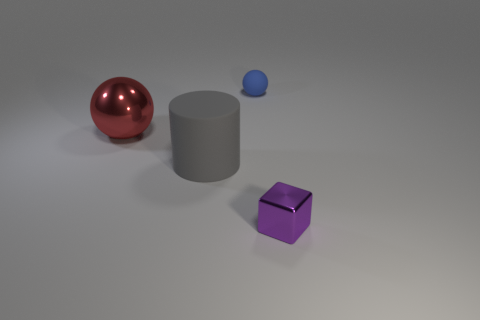There is a shiny object that is right of the matte cylinder; what shape is it?
Offer a very short reply. Cube. How many green objects are tiny metal blocks or big rubber objects?
Offer a terse response. 0. There is a sphere that is made of the same material as the big cylinder; what color is it?
Provide a short and direct response. Blue. Do the big ball and the tiny object right of the small blue ball have the same color?
Your answer should be very brief. No. There is a object that is in front of the large metallic ball and behind the small purple object; what color is it?
Your response must be concise. Gray. What number of large gray cylinders are behind the gray matte cylinder?
Your answer should be very brief. 0. What number of objects are red shiny balls or small objects in front of the big cylinder?
Keep it short and to the point. 2. There is a sphere that is behind the large red metal sphere; are there any small blue matte balls behind it?
Provide a succinct answer. No. There is a metallic thing in front of the big metallic sphere; what color is it?
Ensure brevity in your answer.  Purple. Are there an equal number of blue things on the left side of the small blue matte sphere and small purple metal blocks?
Your answer should be very brief. No. 